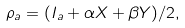<formula> <loc_0><loc_0><loc_500><loc_500>\rho _ { a } = ( I _ { a } + \alpha X + \beta Y ) / 2 ,</formula> 